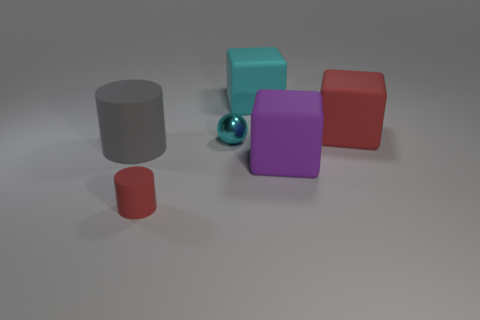How many other things are there of the same shape as the metal thing?
Keep it short and to the point. 0. What number of large things are behind the red matte thing that is behind the small object that is to the left of the sphere?
Keep it short and to the point. 1. Are there more large blue metal blocks than big gray rubber cylinders?
Your response must be concise. No. How many big matte blocks are there?
Your answer should be very brief. 3. There is a red matte thing left of the large red cube that is right of the cylinder to the right of the large gray object; what shape is it?
Keep it short and to the point. Cylinder. Are there fewer large gray rubber cylinders that are in front of the gray rubber cylinder than cyan matte objects behind the big purple block?
Keep it short and to the point. Yes. There is a big thing that is left of the small matte thing; is it the same shape as the red matte object that is left of the tiny cyan ball?
Offer a very short reply. Yes. There is a small object that is right of the matte cylinder that is in front of the gray thing; what is its shape?
Give a very brief answer. Sphere. The matte thing that is the same color as the metal thing is what size?
Offer a terse response. Large. Are there any brown blocks that have the same material as the small red object?
Make the answer very short. No. 